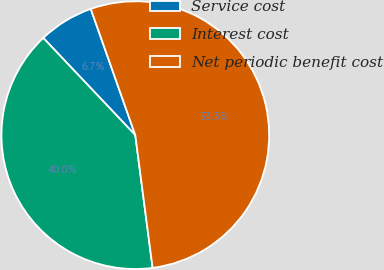<chart> <loc_0><loc_0><loc_500><loc_500><pie_chart><fcel>Service cost<fcel>Interest cost<fcel>Net periodic benefit cost<nl><fcel>6.67%<fcel>40.0%<fcel>53.33%<nl></chart> 